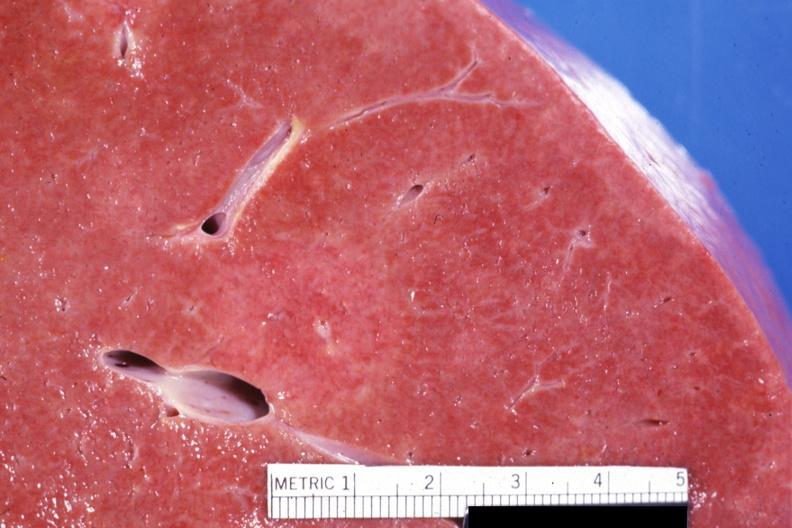s liver present?
Answer the question using a single word or phrase. Yes 